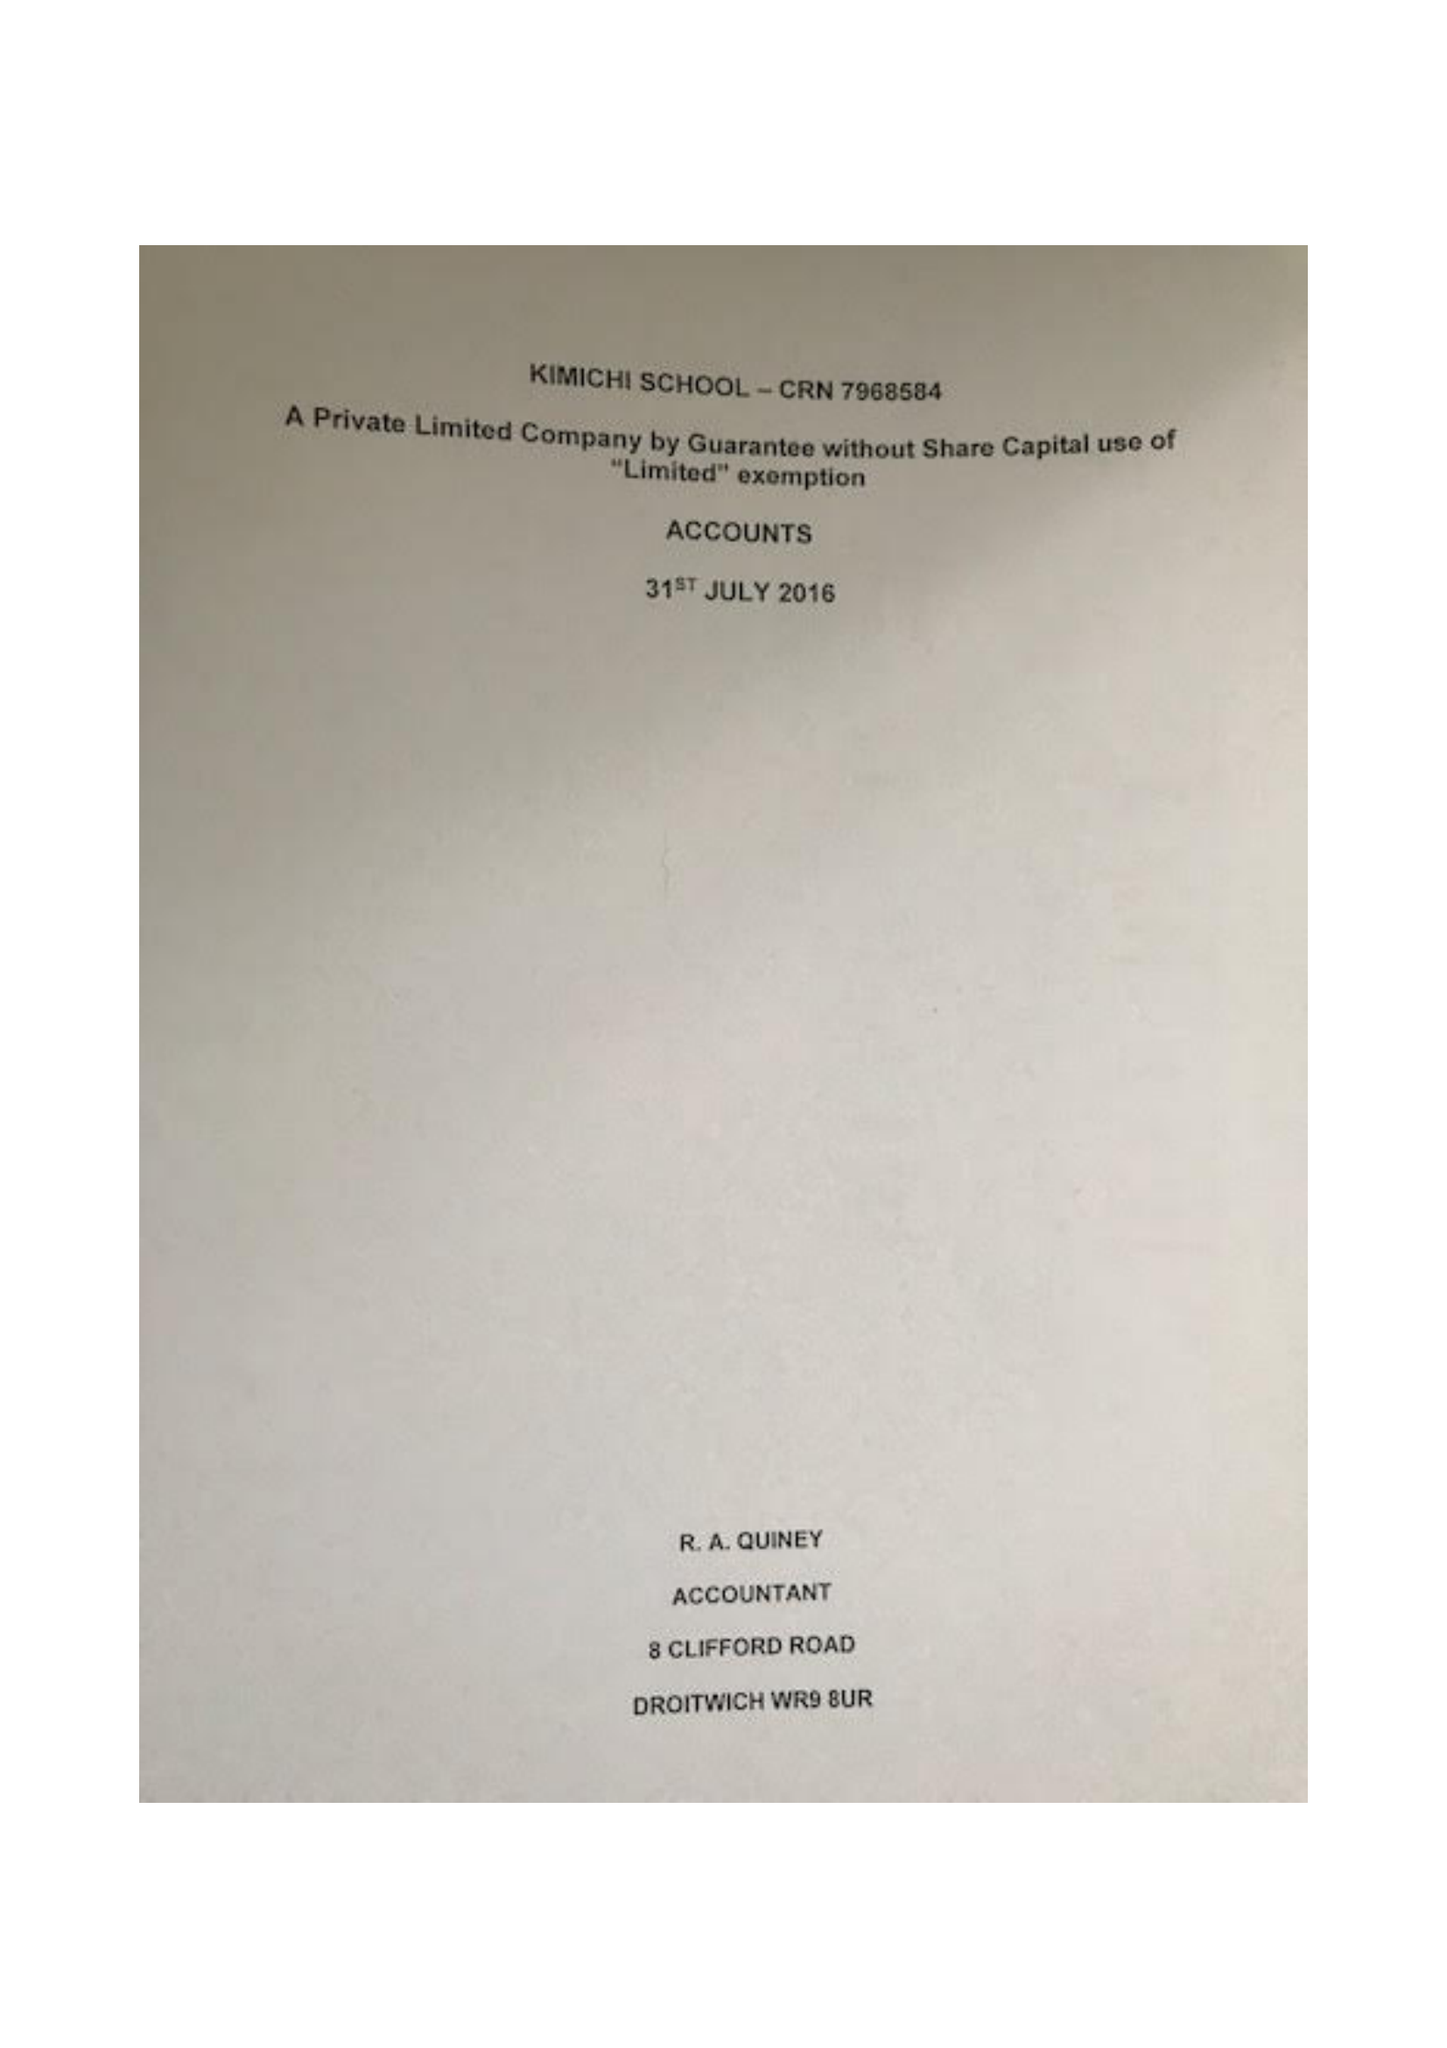What is the value for the charity_name?
Answer the question using a single word or phrase. Kimichi School 